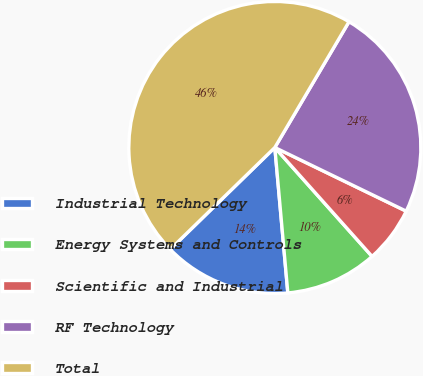Convert chart to OTSL. <chart><loc_0><loc_0><loc_500><loc_500><pie_chart><fcel>Industrial Technology<fcel>Energy Systems and Controls<fcel>Scientific and Industrial<fcel>RF Technology<fcel>Total<nl><fcel>14.13%<fcel>10.18%<fcel>6.22%<fcel>23.7%<fcel>45.77%<nl></chart> 